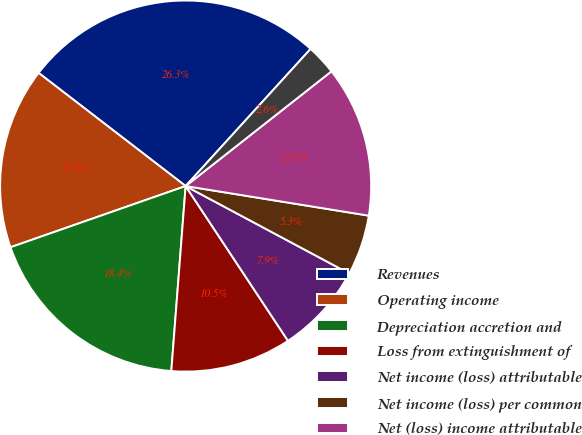<chart> <loc_0><loc_0><loc_500><loc_500><pie_chart><fcel>Revenues<fcel>Operating income<fcel>Depreciation accretion and<fcel>Loss from extinguishment of<fcel>Net income (loss) attributable<fcel>Net income (loss) per common<fcel>Net (loss) income attributable<fcel>Net (loss) income per common<nl><fcel>26.32%<fcel>15.79%<fcel>18.42%<fcel>10.53%<fcel>7.89%<fcel>5.26%<fcel>13.16%<fcel>2.63%<nl></chart> 